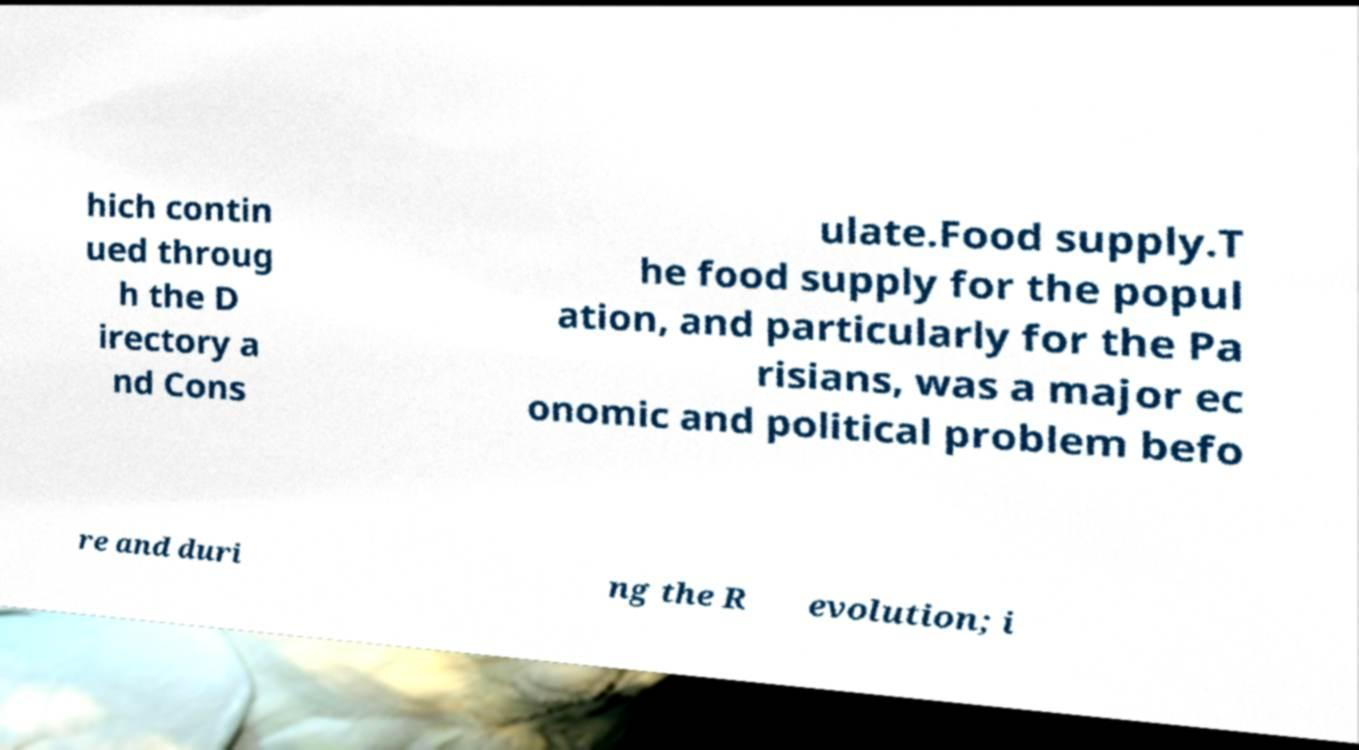What messages or text are displayed in this image? I need them in a readable, typed format. hich contin ued throug h the D irectory a nd Cons ulate.Food supply.T he food supply for the popul ation, and particularly for the Pa risians, was a major ec onomic and political problem befo re and duri ng the R evolution; i 